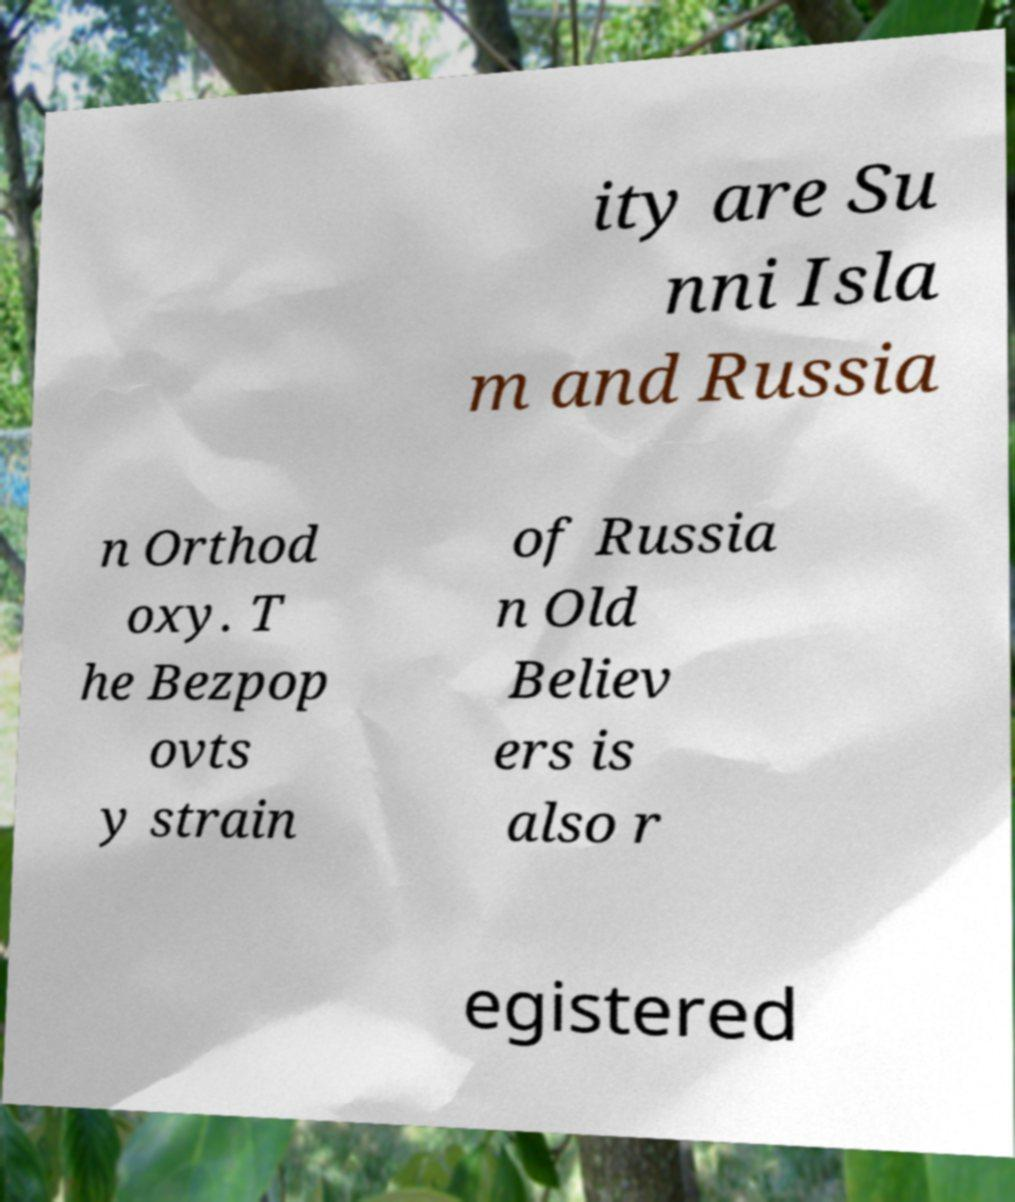Can you accurately transcribe the text from the provided image for me? ity are Su nni Isla m and Russia n Orthod oxy. T he Bezpop ovts y strain of Russia n Old Believ ers is also r egistered 